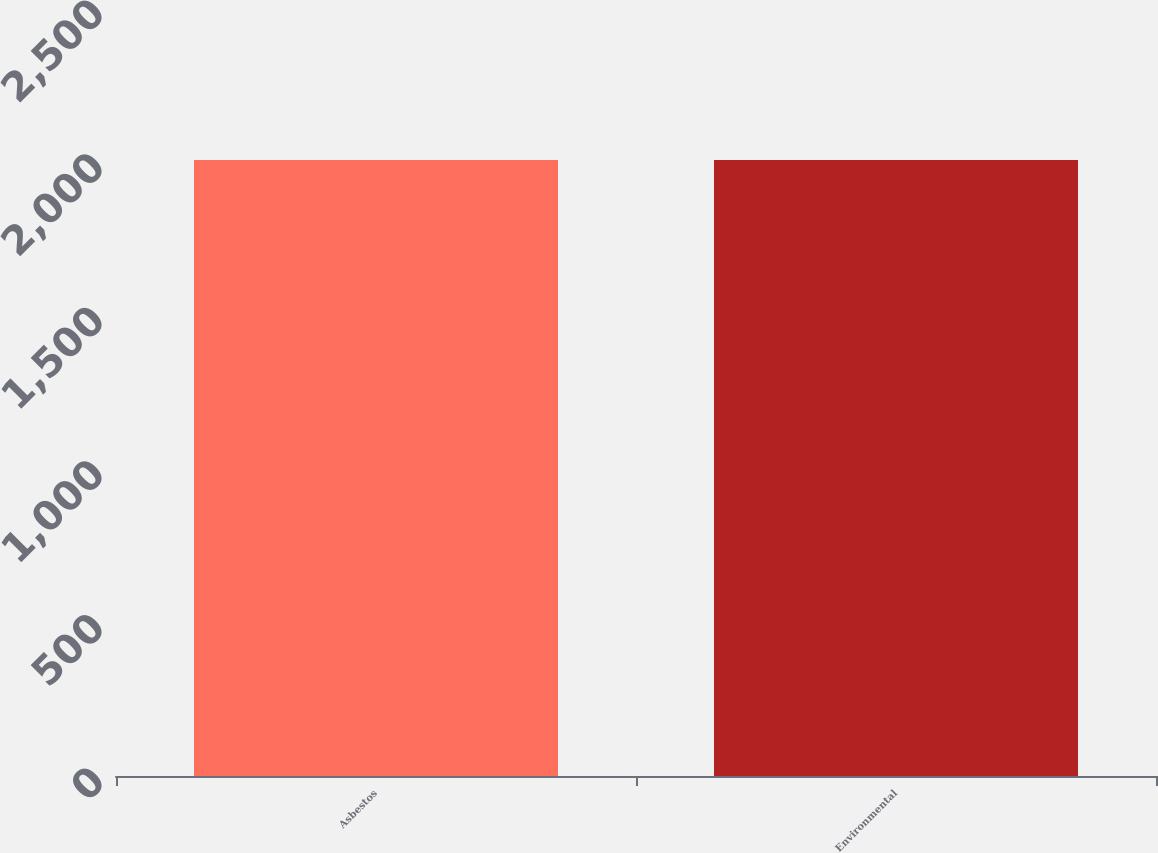<chart> <loc_0><loc_0><loc_500><loc_500><bar_chart><fcel>Asbestos<fcel>Environmental<nl><fcel>2005<fcel>2005.1<nl></chart> 